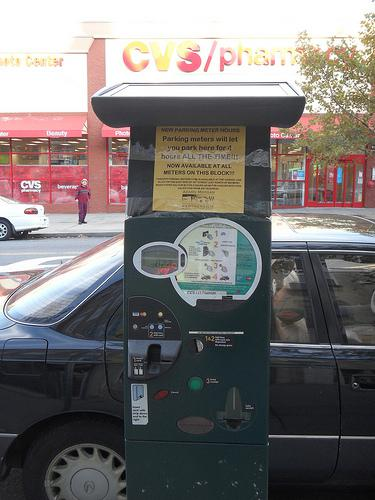Question: who is the name of the pharmacy?
Choices:
A. Walgreens.
B. Eckerds.
C. Rite Aid.
D. CVS.
Answer with the letter. Answer: D Question: what color is the car closest?
Choices:
A. Teal.
B. Purple.
C. Neon.
D. Black.
Answer with the letter. Answer: D Question: how do you pay for parking?
Choices:
A. At attendant booth.
B. At the machine.
C. With credit card.
D. With debit card.
Answer with the letter. Answer: B Question: when should you pay for parking?
Choices:
A. When you handle the ticket to the parking assistant.
B. Before you leave your car.
C. Before you leave the parking garage.
D. When you first park.
Answer with the letter. Answer: D Question: what color is the car furthest away?
Choices:
A. Teal.
B. Purple.
C. Neon.
D. White.
Answer with the letter. Answer: D 